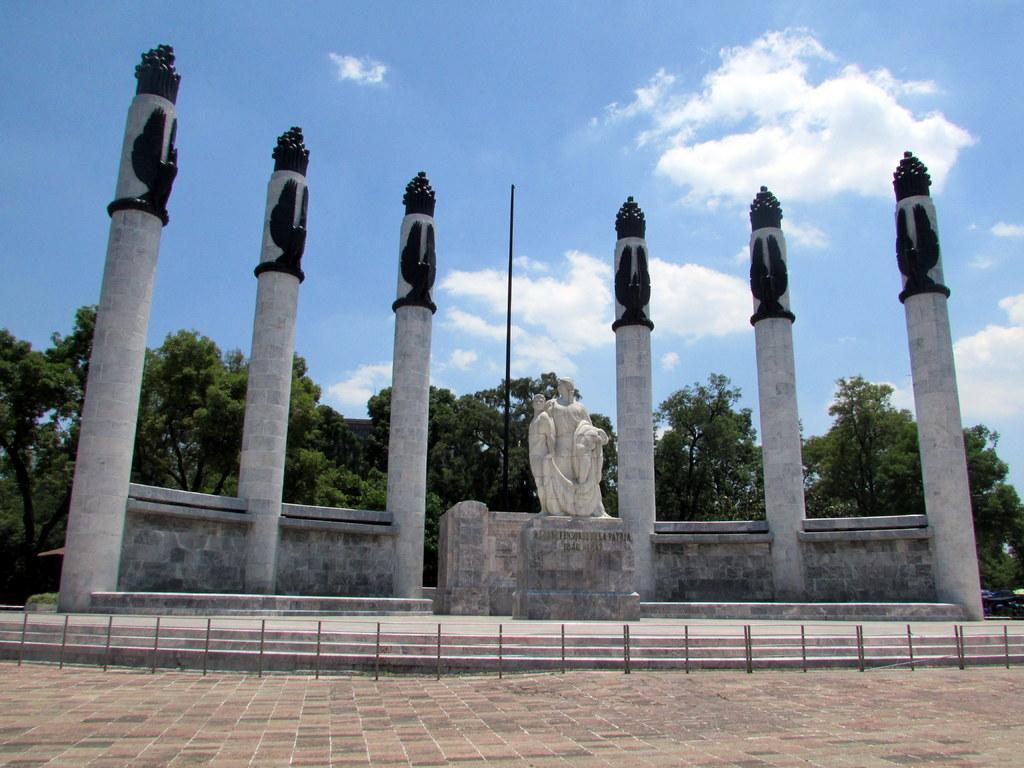Could you give a brief overview of what you see in this image? At the bottom of the image we can see a fencing. Behind the fencing there is a statue. Behind the statue there are some poles and pillars. Behind them there are some trees. At the top of the image there are some clouds in the sky. 